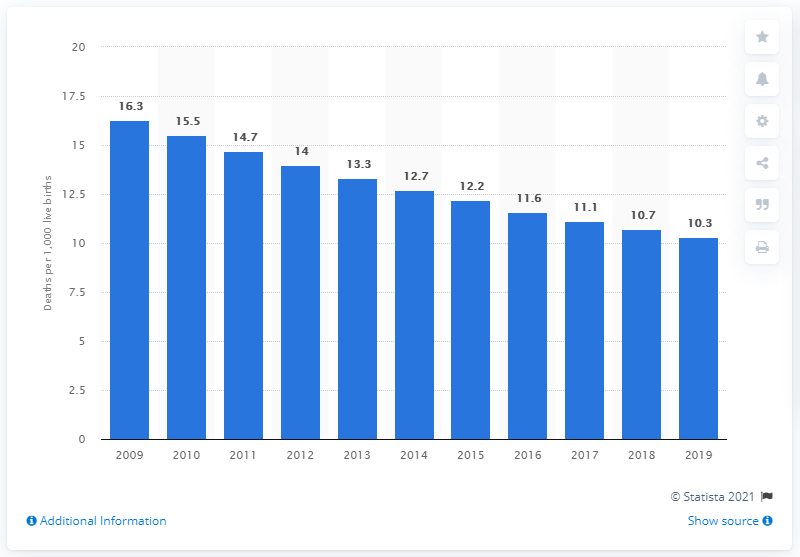Specify some key components in this picture. In 2019, the infant mortality rate in Peru was 10.3 deaths per 1,000 live births. 